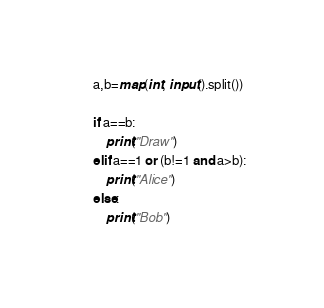Convert code to text. <code><loc_0><loc_0><loc_500><loc_500><_Python_>a,b=map(int, input().split())

if a==b:
    print("Draw")
elif a==1 or (b!=1 and a>b):
    print("Alice")
else:
    print("Bob")
</code> 